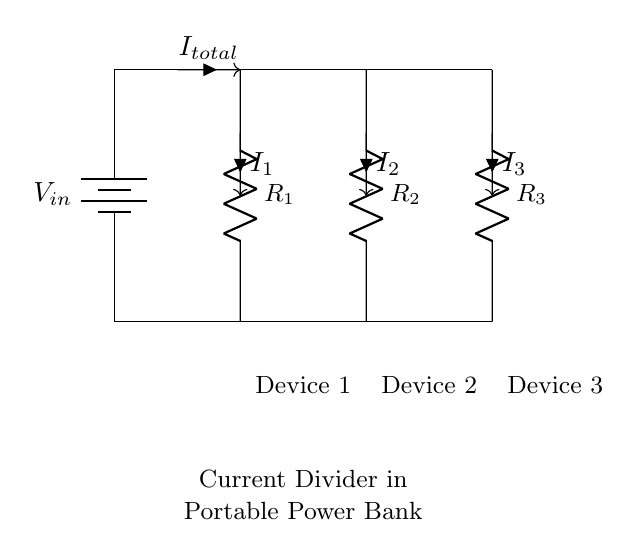What is the input voltage for the circuit? The input voltage is denoted as V_in, which is the voltage from the battery supplying the circuit.
Answer: V_in How many resistors are in the circuit? There are three resistors connected in parallel: R_1, R_2, and R_3.
Answer: 3 What is the total current entering the circuit? The total current entering the circuit is indicated as I_total, which is the current flowing from the battery before it divides among the devices.
Answer: I_total Which devices are connected to the output of the resistors? The devices connected are Device 1, Device 2, and Device 3, identified by labels beneath the resistors.
Answer: Device 1, Device 2, Device 3 How is the current divided among the resistors? The current is divided according to the resistance values; each resistor gets a portion of the total current inversely proportional to its resistance. Lower resistance allows more current to flow through it.
Answer: Inversely proportional to resistance What happens to the current if one device is disconnected? If one device is disconnected, the current that was flowing through its corresponding resistor will redistribute among the remaining resistors, increasing their current flow.
Answer: Redistributes among remaining resistors If R_1, R_2, and R_3 are equal, how is the current divided among them? If R_1, R_2, and R_3 are equal, the total current I_total will be equally divided into three parts, each resistor will have a current of I_total divided by 3.
Answer: I_total divided by 3 